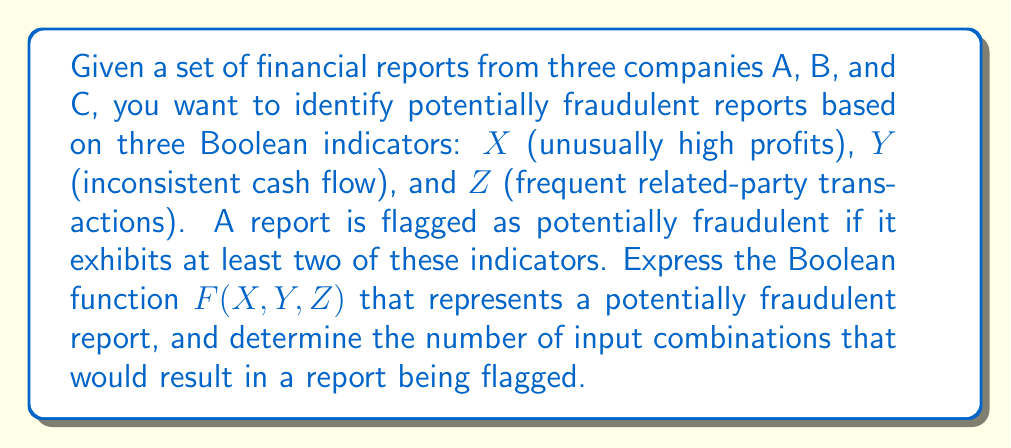Give your solution to this math problem. 1) First, we need to express the Boolean function $F(X,Y,Z)$ that represents a potentially fraudulent report. A report is flagged if it exhibits at least two of the three indicators. This can be represented as:

   $F(X,Y,Z) = XY + XZ + YZ$

   Where '+' represents the OR operation, and the product represents the AND operation.

2) To determine the number of input combinations that result in a report being flagged, we need to count the number of cases where $F(X,Y,Z) = 1$.

3) Let's consider all possible input combinations:

   $F(0,0,0) = 0 \cdot 0 + 0 \cdot 0 + 0 \cdot 0 = 0$
   $F(0,0,1) = 0 \cdot 0 + 0 \cdot 1 + 0 \cdot 1 = 0$
   $F(0,1,0) = 0 \cdot 1 + 0 \cdot 0 + 1 \cdot 0 = 0$
   $F(0,1,1) = 0 \cdot 1 + 0 \cdot 1 + 1 \cdot 1 = 1$
   $F(1,0,0) = 1 \cdot 0 + 1 \cdot 0 + 0 \cdot 0 = 0$
   $F(1,0,1) = 1 \cdot 0 + 1 \cdot 1 + 0 \cdot 1 = 1$
   $F(1,1,0) = 1 \cdot 1 + 1 \cdot 0 + 1 \cdot 0 = 1$
   $F(1,1,1) = 1 \cdot 1 + 1 \cdot 1 + 1 \cdot 1 = 1$

4) Counting the number of times $F(X,Y,Z) = 1$, we get 4 combinations.
Answer: $F(X,Y,Z) = XY + XZ + YZ$; 4 combinations 